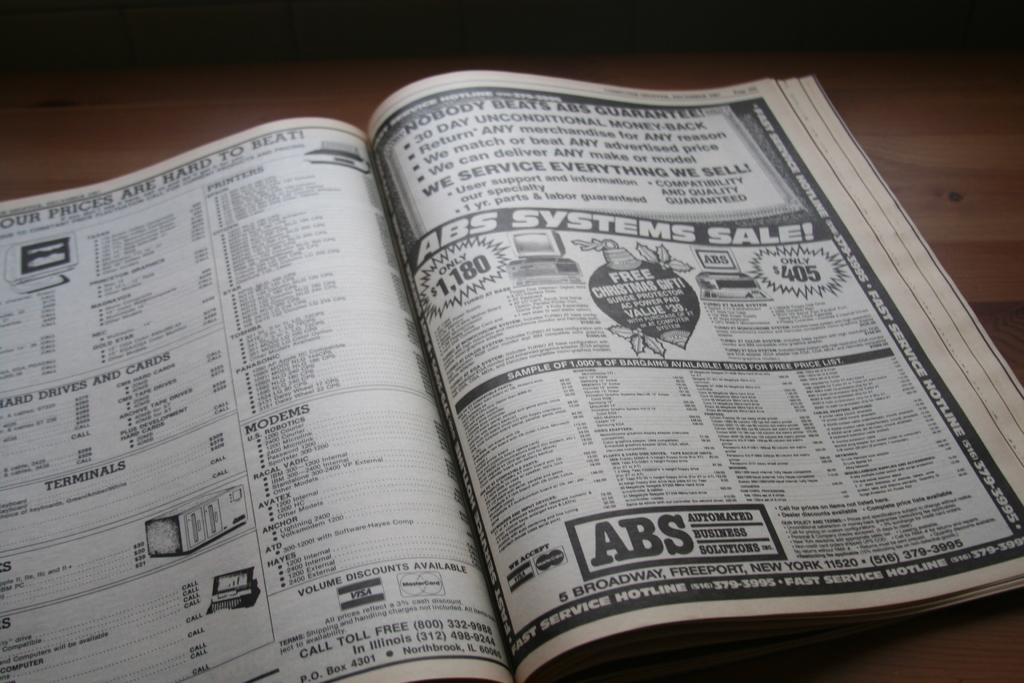<image>
Create a compact narrative representing the image presented. A book of advertisements with one at the bottom of the right page saying ABS. 